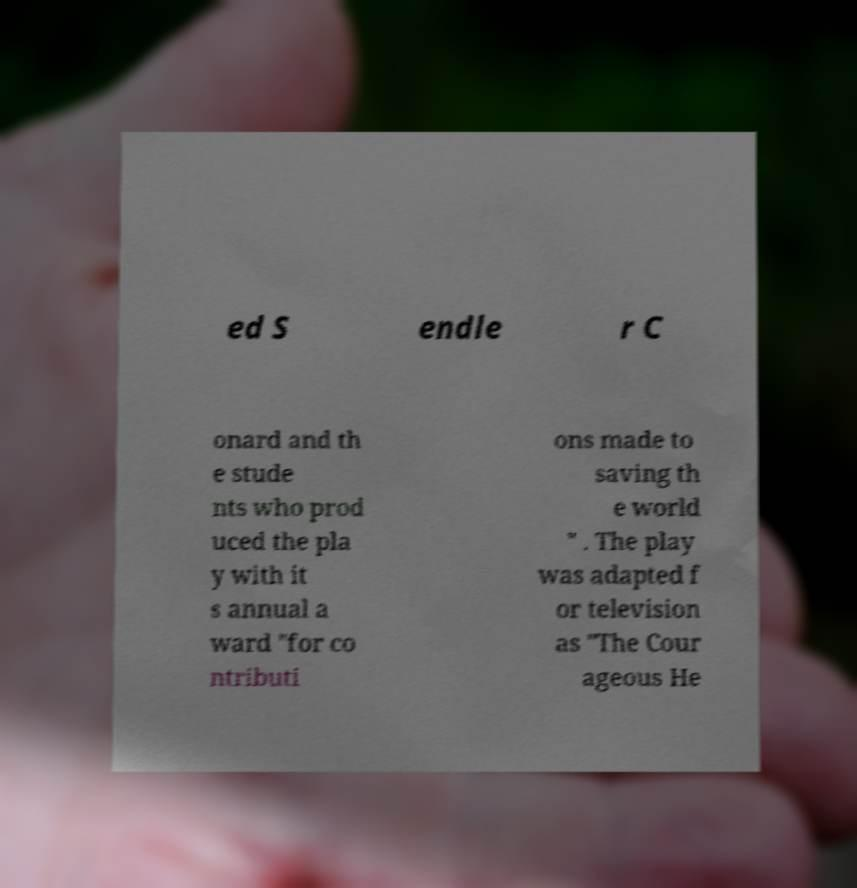I need the written content from this picture converted into text. Can you do that? ed S endle r C onard and th e stude nts who prod uced the pla y with it s annual a ward "for co ntributi ons made to saving th e world " . The play was adapted f or television as "The Cour ageous He 